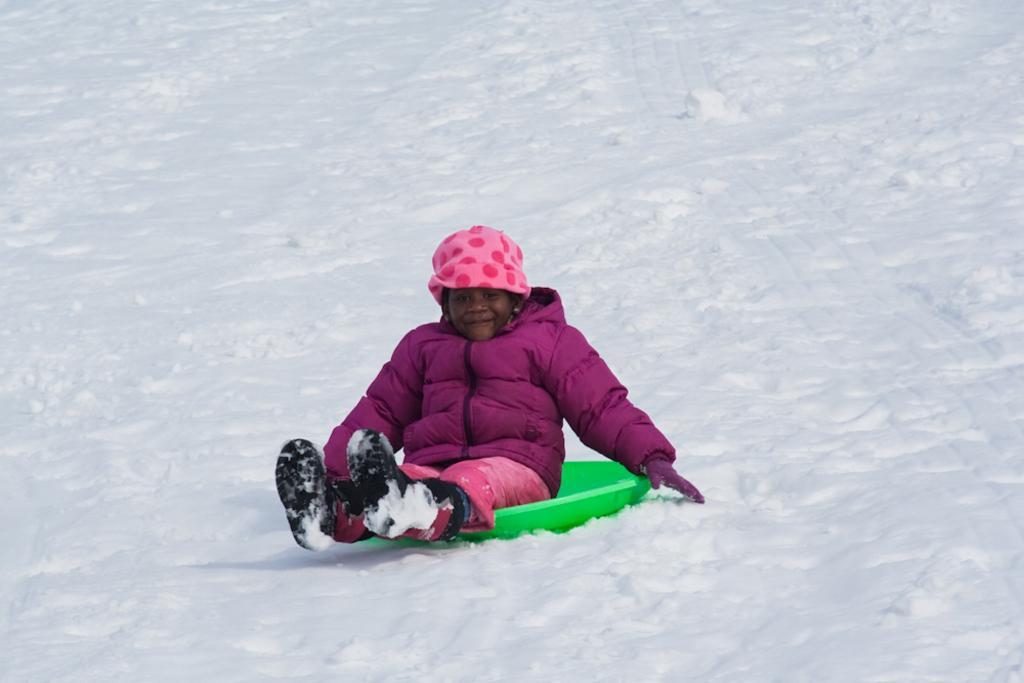Please provide a concise description of this image. In this image I can see a snow. And a person sitting on the object and wearing a jacket. 